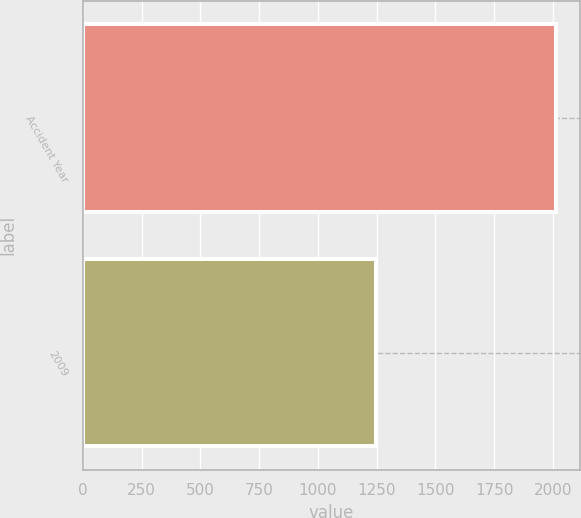Convert chart to OTSL. <chart><loc_0><loc_0><loc_500><loc_500><bar_chart><fcel>Accident Year<fcel>2009<nl><fcel>2015<fcel>1246<nl></chart> 